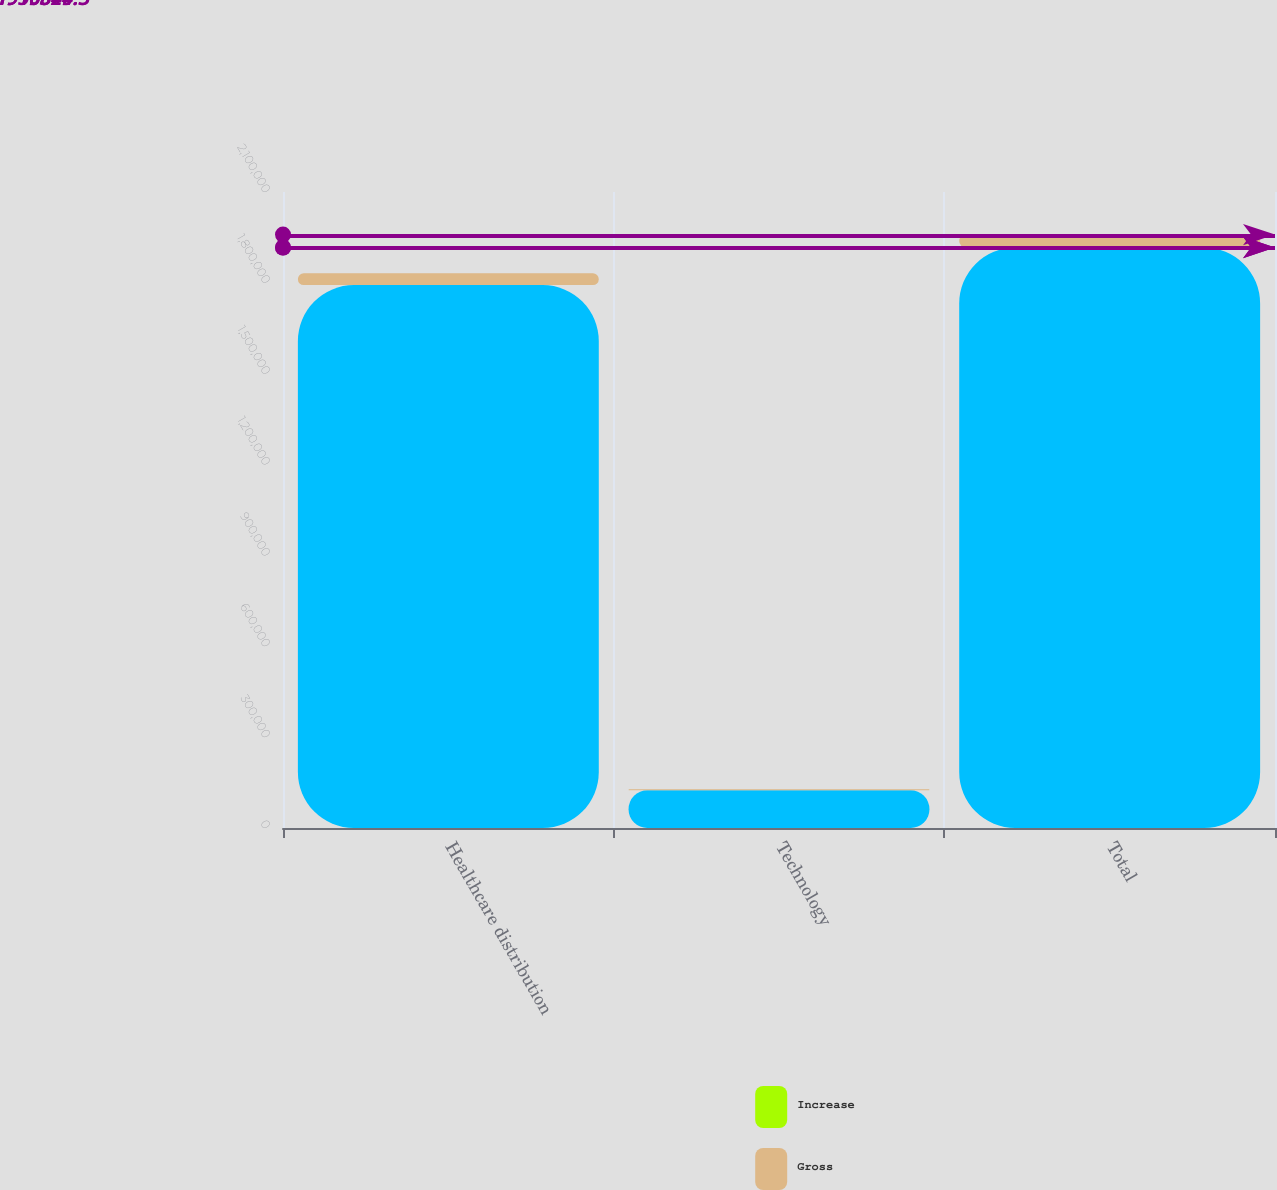Convert chart. <chart><loc_0><loc_0><loc_500><loc_500><stacked_bar_chart><ecel><fcel>Healthcare distribution<fcel>Technology<fcel>Total<nl><fcel>nan<fcel>1.79252e+06<fcel>124304<fcel>1.91682e+06<nl><fcel>Increase<fcel>28.2<fcel>71.8<fcel>29.3<nl><fcel>Gross<fcel>38861<fcel>3664<fcel>42525<nl></chart> 